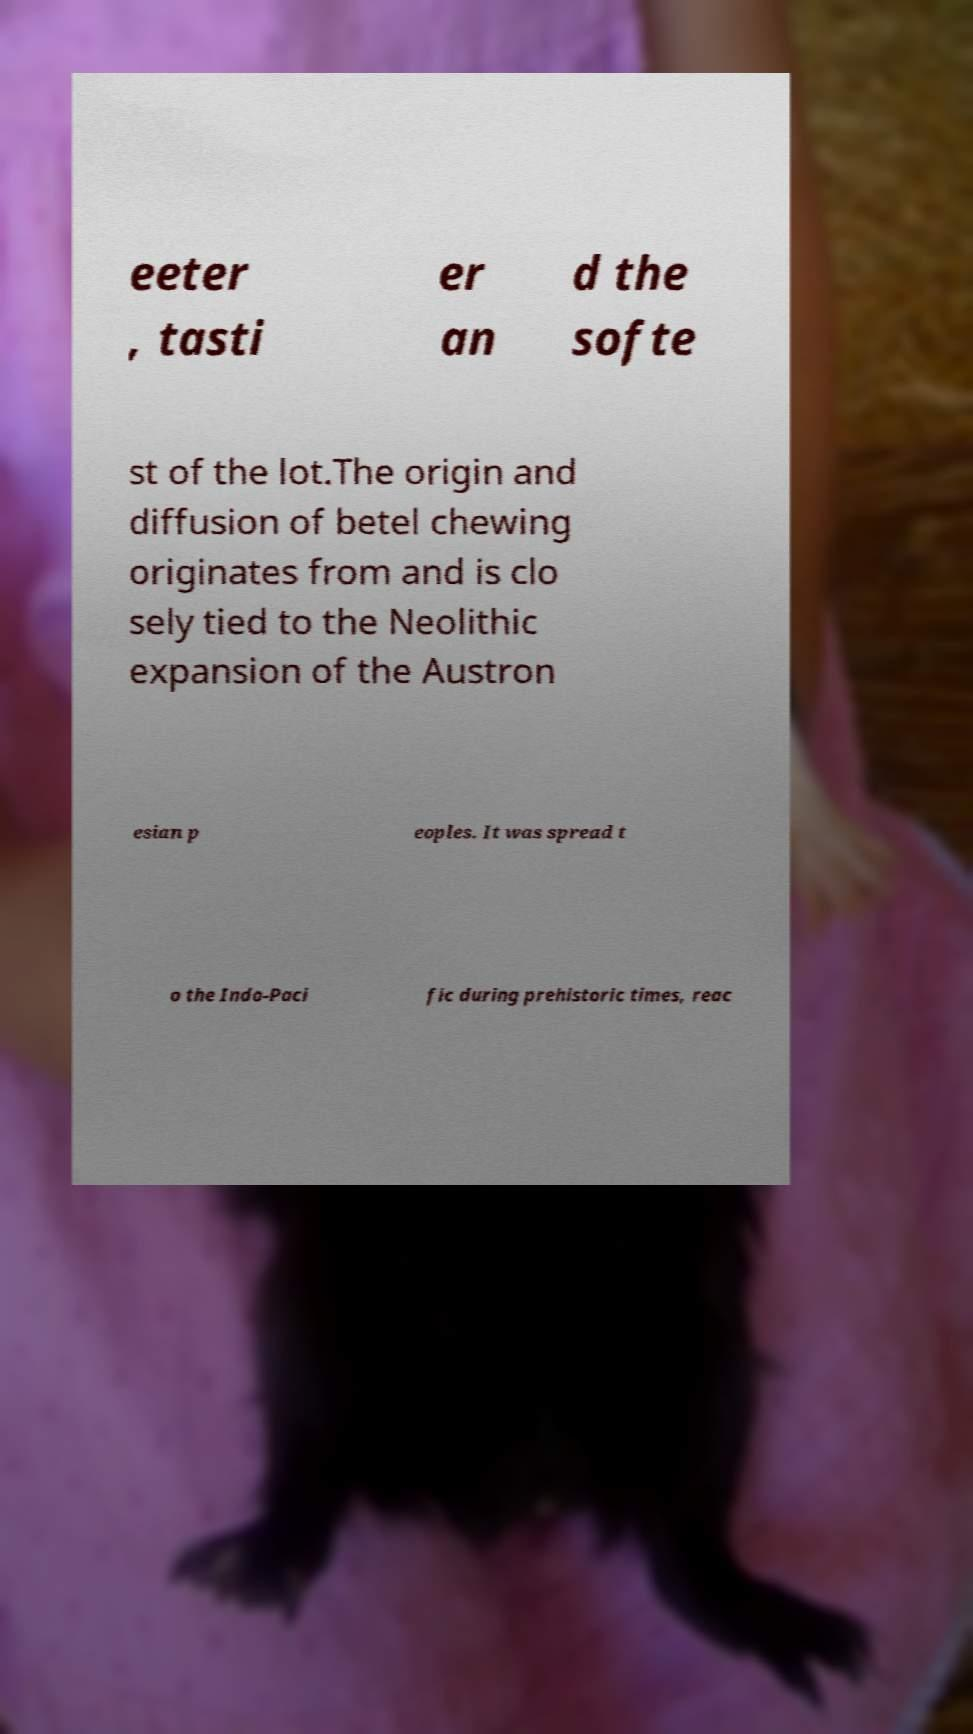Can you read and provide the text displayed in the image?This photo seems to have some interesting text. Can you extract and type it out for me? eeter , tasti er an d the softe st of the lot.The origin and diffusion of betel chewing originates from and is clo sely tied to the Neolithic expansion of the Austron esian p eoples. It was spread t o the Indo-Paci fic during prehistoric times, reac 